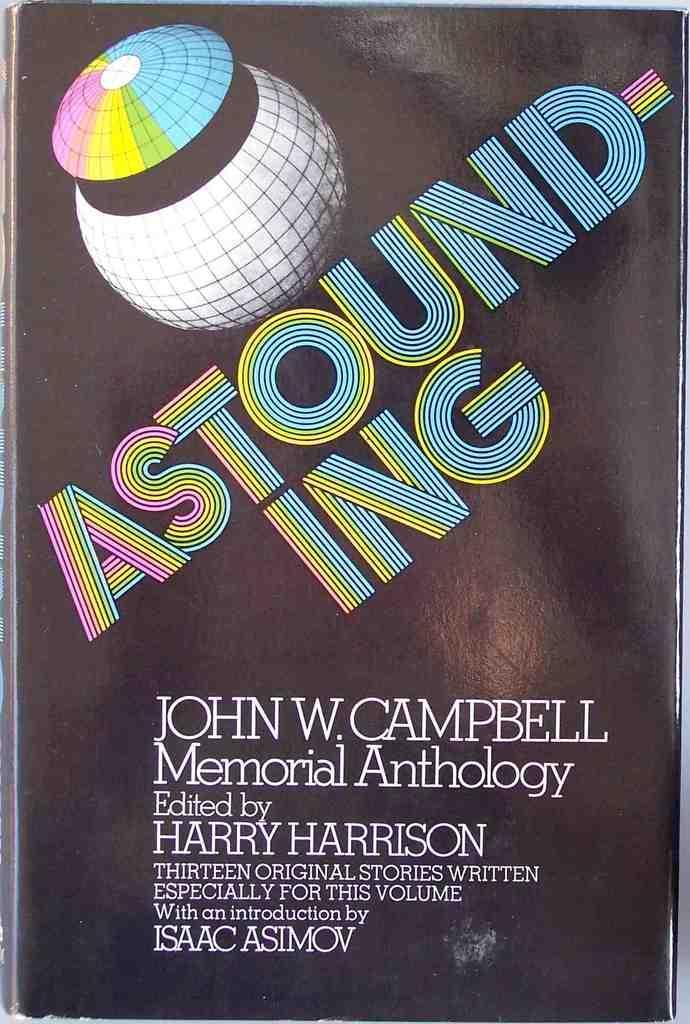How would you summarize this image in a sentence or two? In this picture I can see there is a cover page of a book and there is an image on it, there is something written on it. 